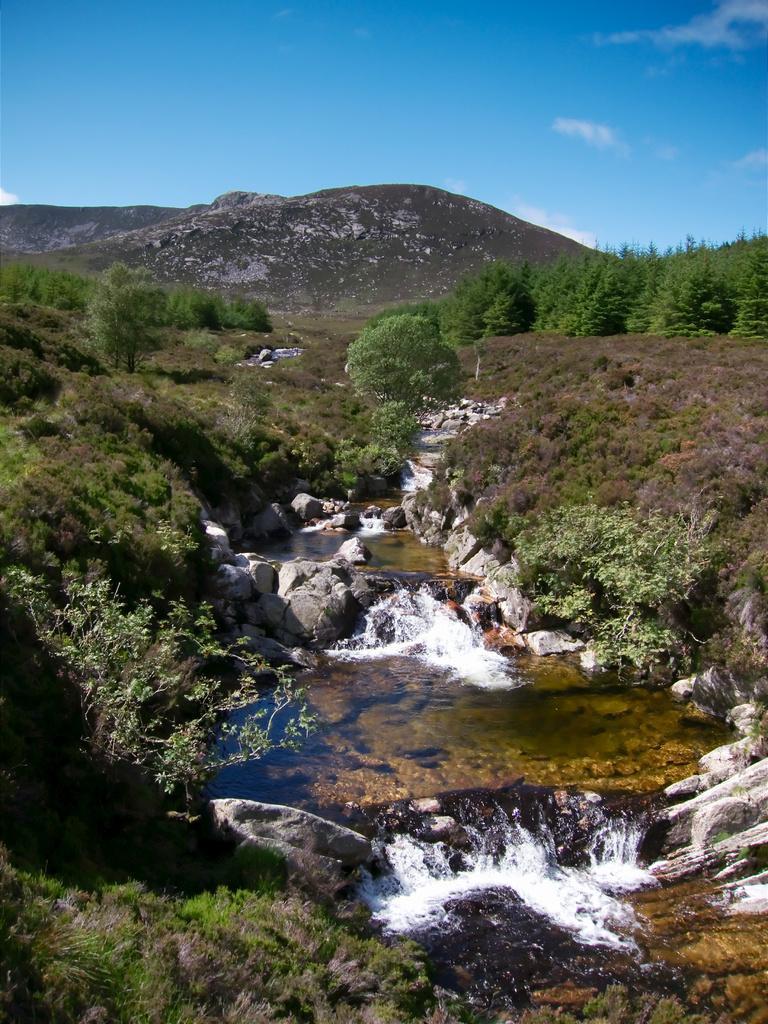Could you give a brief overview of what you see in this image? In this picture I can see the water flow, beside that I can see many stones. On the right and left side I can see many trees, plants and grass. In the background I can see the mountain. At the top I can see the sky and clouds. 